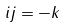<formula> <loc_0><loc_0><loc_500><loc_500>i j = - k</formula> 